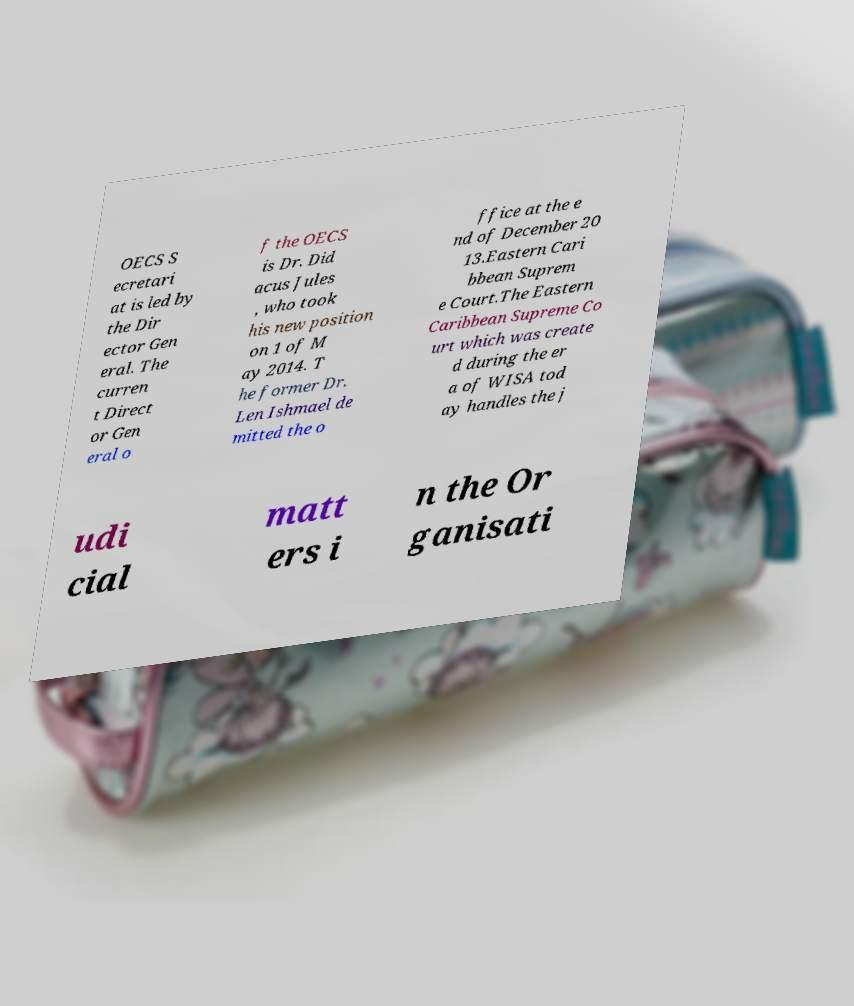Please identify and transcribe the text found in this image. OECS S ecretari at is led by the Dir ector Gen eral. The curren t Direct or Gen eral o f the OECS is Dr. Did acus Jules , who took his new position on 1 of M ay 2014. T he former Dr. Len Ishmael de mitted the o ffice at the e nd of December 20 13.Eastern Cari bbean Suprem e Court.The Eastern Caribbean Supreme Co urt which was create d during the er a of WISA tod ay handles the j udi cial matt ers i n the Or ganisati 